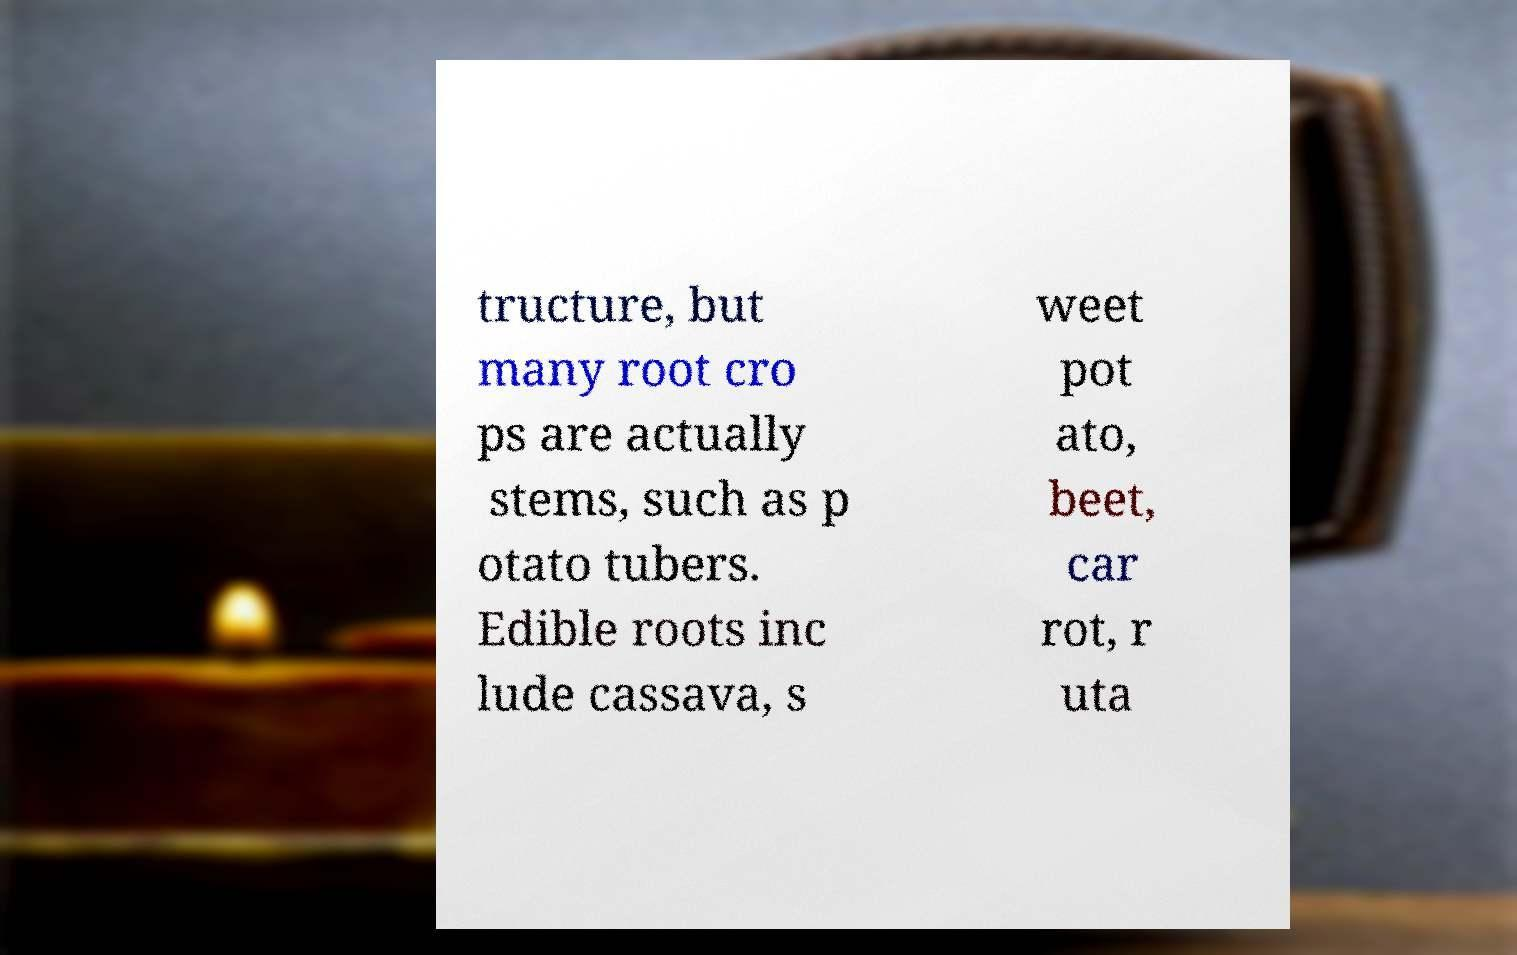Please read and relay the text visible in this image. What does it say? tructure, but many root cro ps are actually stems, such as p otato tubers. Edible roots inc lude cassava, s weet pot ato, beet, car rot, r uta 